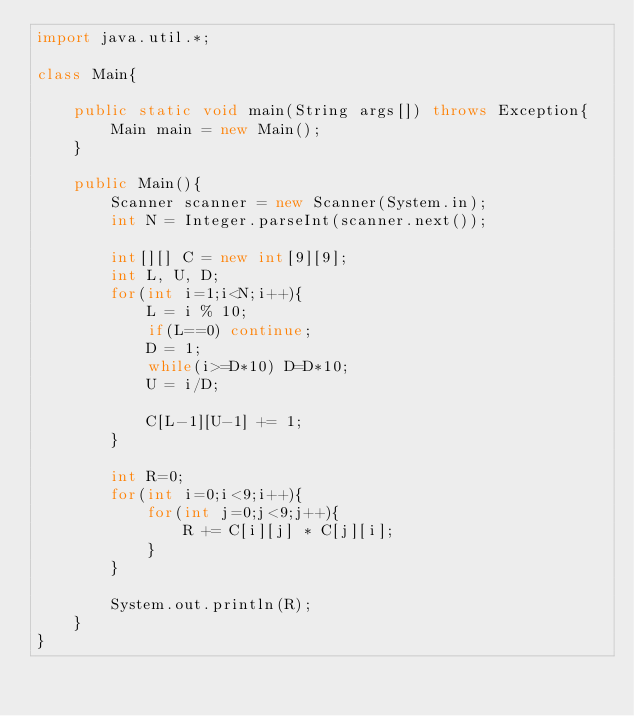<code> <loc_0><loc_0><loc_500><loc_500><_Java_>import java.util.*;

class Main{

    public static void main(String args[]) throws Exception{
        Main main = new Main();
    }

    public Main(){
        Scanner scanner = new Scanner(System.in);
        int N = Integer.parseInt(scanner.next());

        int[][] C = new int[9][9];
        int L, U, D;
        for(int i=1;i<N;i++){
            L = i % 10;
            if(L==0) continue;
            D = 1;
            while(i>=D*10) D=D*10;
            U = i/D;

            C[L-1][U-1] += 1;
        }

        int R=0;
        for(int i=0;i<9;i++){
            for(int j=0;j<9;j++){
                R += C[i][j] * C[j][i];
            }
        }

        System.out.println(R);
    }
}
</code> 